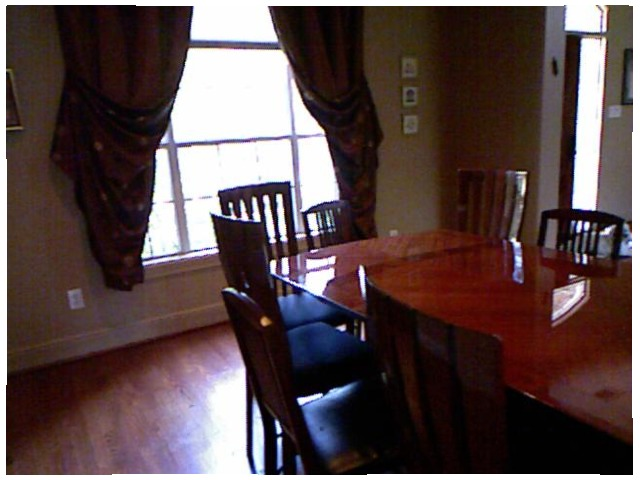<image>
Is the reflection under the window? No. The reflection is not positioned under the window. The vertical relationship between these objects is different. Is there a chair on the table? No. The chair is not positioned on the table. They may be near each other, but the chair is not supported by or resting on top of the table. Is the chair to the right of the chair? No. The chair is not to the right of the chair. The horizontal positioning shows a different relationship. 